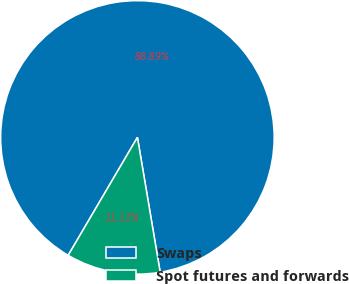<chart> <loc_0><loc_0><loc_500><loc_500><pie_chart><fcel>Swaps<fcel>Spot futures and forwards<nl><fcel>88.89%<fcel>11.11%<nl></chart> 